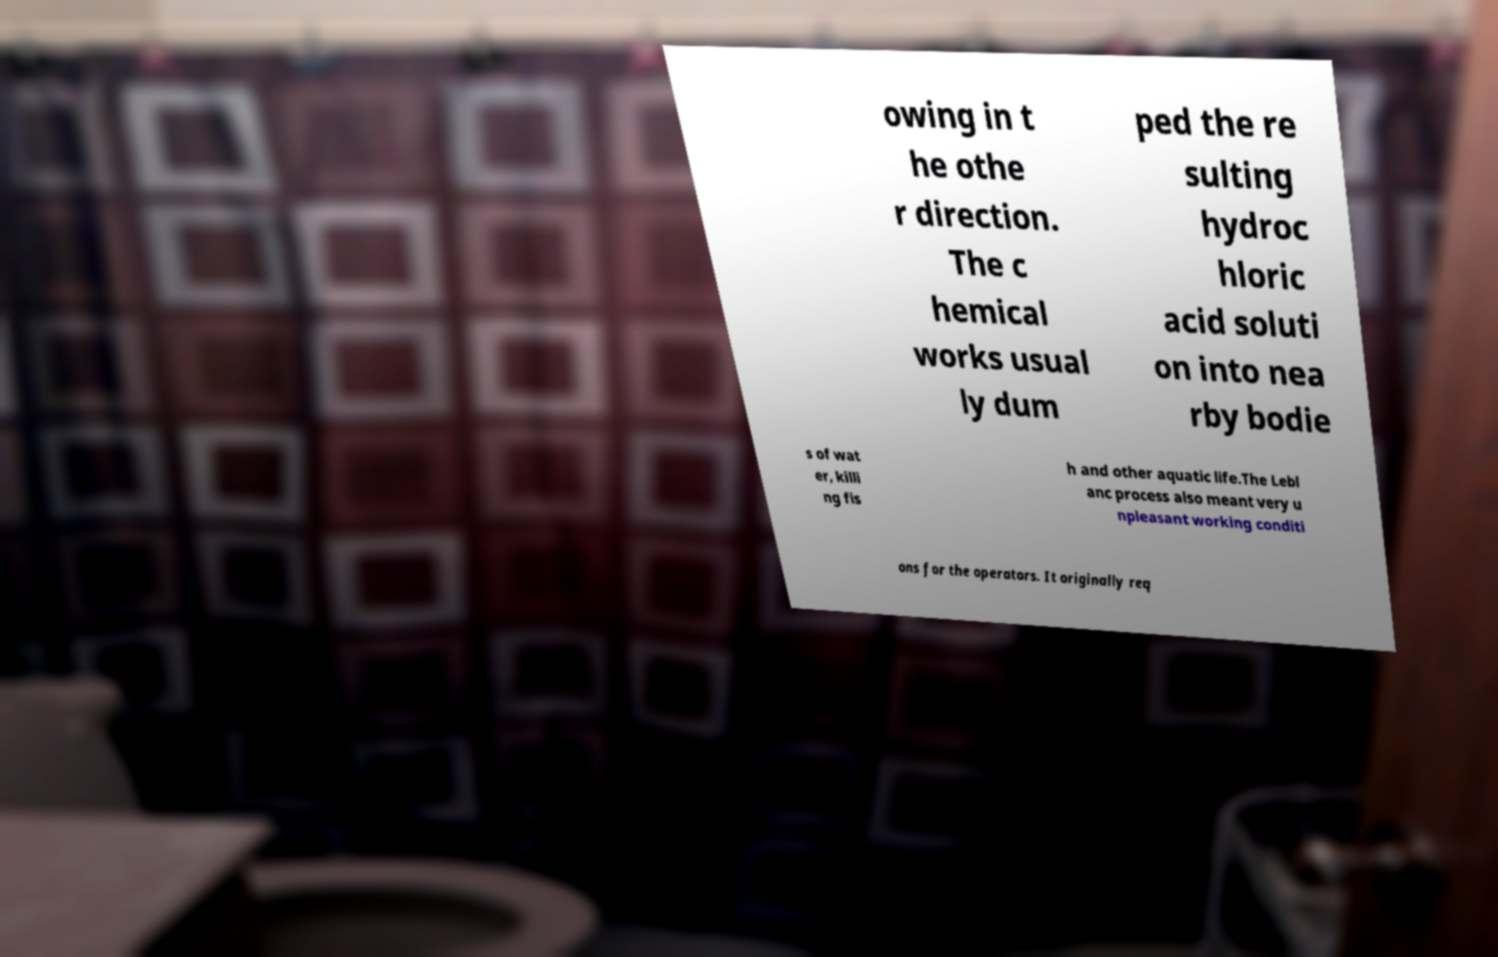Can you read and provide the text displayed in the image?This photo seems to have some interesting text. Can you extract and type it out for me? owing in t he othe r direction. The c hemical works usual ly dum ped the re sulting hydroc hloric acid soluti on into nea rby bodie s of wat er, killi ng fis h and other aquatic life.The Lebl anc process also meant very u npleasant working conditi ons for the operators. It originally req 